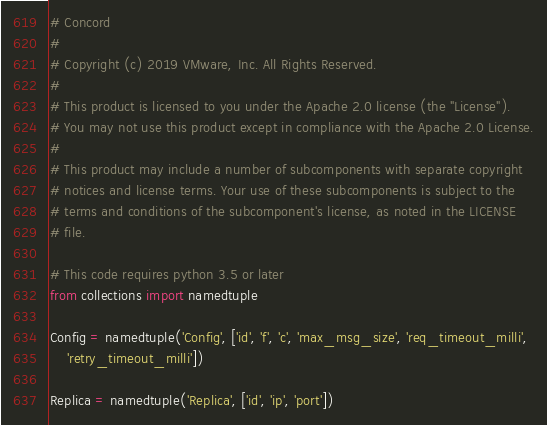<code> <loc_0><loc_0><loc_500><loc_500><_Python_># Concord
#
# Copyright (c) 2019 VMware, Inc. All Rights Reserved.
#
# This product is licensed to you under the Apache 2.0 license (the "License").
# You may not use this product except in compliance with the Apache 2.0 License.
#
# This product may include a number of subcomponents with separate copyright
# notices and license terms. Your use of these subcomponents is subject to the
# terms and conditions of the subcomponent's license, as noted in the LICENSE
# file.

# This code requires python 3.5 or later
from collections import namedtuple

Config = namedtuple('Config', ['id', 'f', 'c', 'max_msg_size', 'req_timeout_milli',
    'retry_timeout_milli'])

Replica = namedtuple('Replica', ['id', 'ip', 'port'])
</code> 